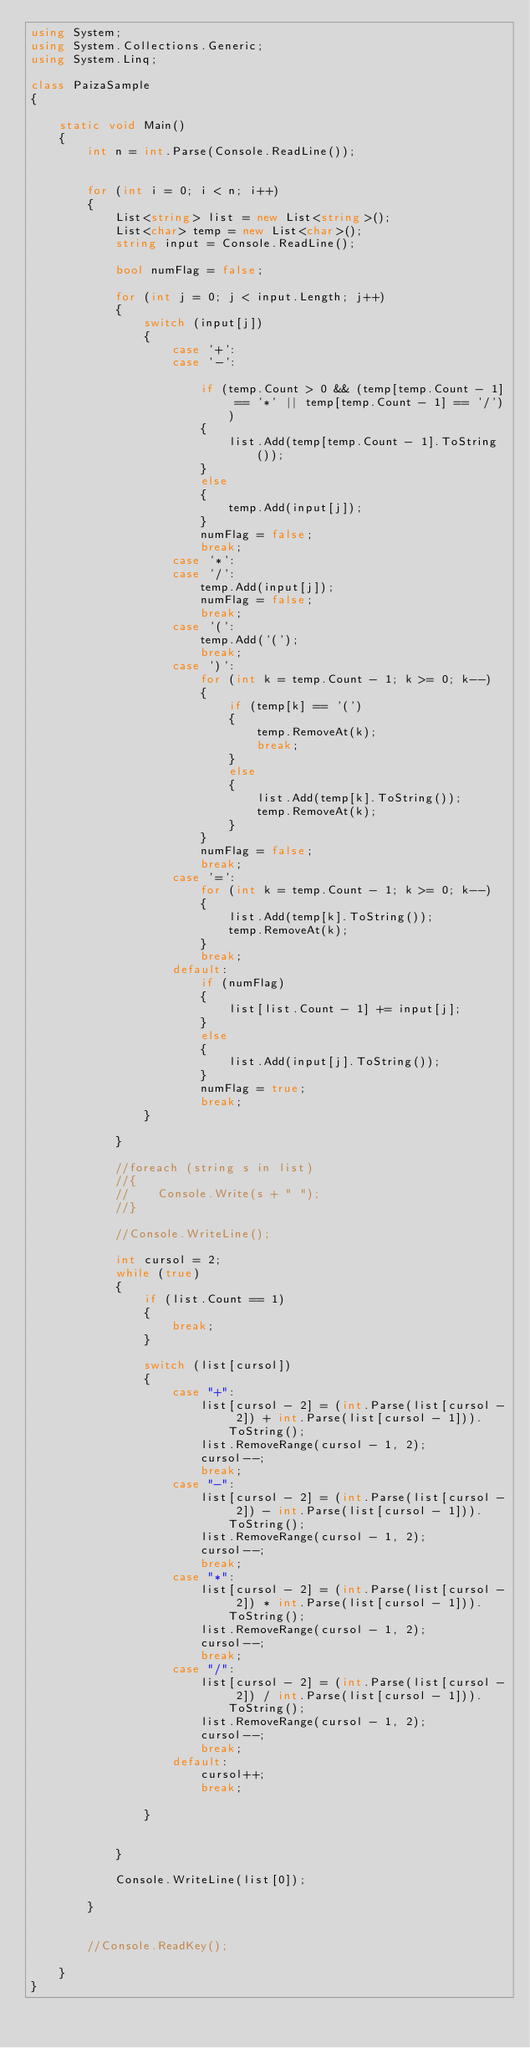<code> <loc_0><loc_0><loc_500><loc_500><_C#_>using System;
using System.Collections.Generic;
using System.Linq;

class PaizaSample
{

    static void Main()
    {
        int n = int.Parse(Console.ReadLine());


        for (int i = 0; i < n; i++)
        {
            List<string> list = new List<string>();
            List<char> temp = new List<char>();
            string input = Console.ReadLine();

            bool numFlag = false;

            for (int j = 0; j < input.Length; j++)
            {
                switch (input[j])
                {
                    case '+':
                    case '-':
                        
                        if (temp.Count > 0 && (temp[temp.Count - 1] == '*' || temp[temp.Count - 1] == '/'))
                        {
                            list.Add(temp[temp.Count - 1].ToString());
                        }
                        else
                        {
                            temp.Add(input[j]);
                        }
                        numFlag = false;
                        break;
                    case '*':
                    case '/':
                        temp.Add(input[j]);
                        numFlag = false;
                        break;
                    case '(':
                        temp.Add('(');
                        break;
                    case ')':
                        for (int k = temp.Count - 1; k >= 0; k--)
                        {
                            if (temp[k] == '(')
                            {
                                temp.RemoveAt(k);
                                break;
                            }
                            else
                            {
                                list.Add(temp[k].ToString());
                                temp.RemoveAt(k);
                            }
                        }
                        numFlag = false;
                        break;
                    case '=':
                        for (int k = temp.Count - 1; k >= 0; k--)
                        {
                            list.Add(temp[k].ToString());
                            temp.RemoveAt(k);
                        }
                        break;
                    default:
                        if (numFlag)
                        {
                            list[list.Count - 1] += input[j];
                        }
                        else
                        {
                            list.Add(input[j].ToString());
                        }
                        numFlag = true;
                        break;
                }

            }

            //foreach (string s in list)
            //{
            //    Console.Write(s + " ");
            //}

            //Console.WriteLine();

            int cursol = 2;
            while (true)
            {
                if (list.Count == 1)
                {
                    break;
                }

                switch (list[cursol])
                {
                    case "+":
                        list[cursol - 2] = (int.Parse(list[cursol - 2]) + int.Parse(list[cursol - 1])).ToString();
                        list.RemoveRange(cursol - 1, 2);
                        cursol--;
                        break;
                    case "-":
                        list[cursol - 2] = (int.Parse(list[cursol - 2]) - int.Parse(list[cursol - 1])).ToString();
                        list.RemoveRange(cursol - 1, 2);
                        cursol--;
                        break;
                    case "*":
                        list[cursol - 2] = (int.Parse(list[cursol - 2]) * int.Parse(list[cursol - 1])).ToString();
                        list.RemoveRange(cursol - 1, 2);
                        cursol--;
                        break;
                    case "/":
                        list[cursol - 2] = (int.Parse(list[cursol - 2]) / int.Parse(list[cursol - 1])).ToString();
                        list.RemoveRange(cursol - 1, 2);
                        cursol--;
                        break;
                    default:
                        cursol++;
                        break;

                }


            }

            Console.WriteLine(list[0]);

        }


        //Console.ReadKey();

    }
}</code> 